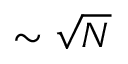<formula> <loc_0><loc_0><loc_500><loc_500>\sim \sqrt { N }</formula> 